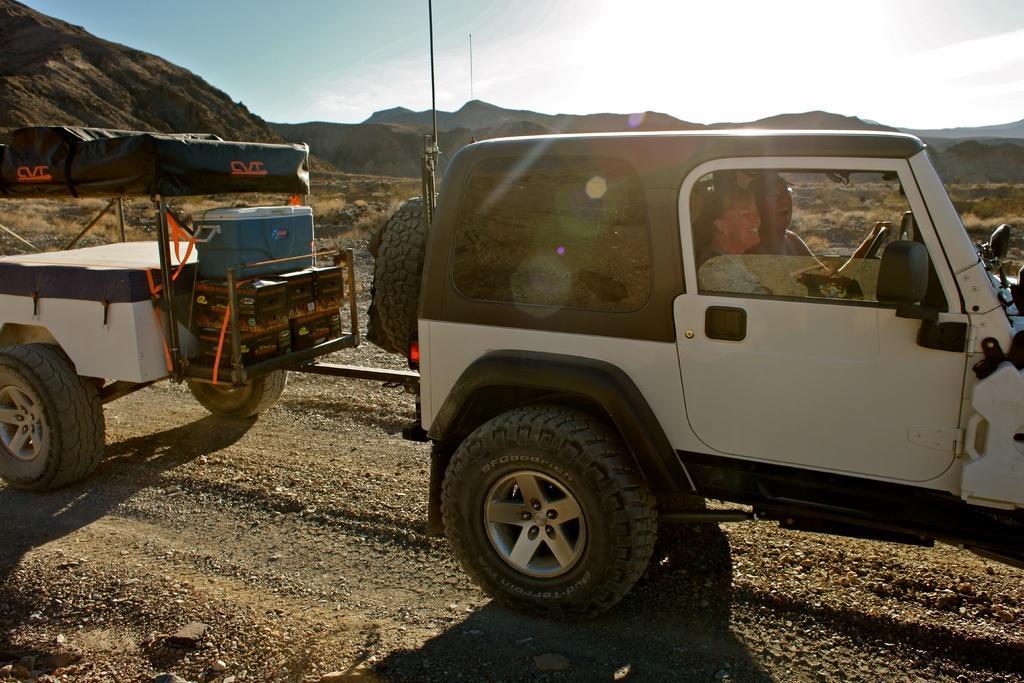Can you describe this image briefly? In this image I can see a vehicle which is white and black in color on the road and two persons sitting in the vehicle. Behind it I can see another vehicle which is white and black in color and few boxes in it. In the background I can see few mountains, the sky and some grass on the ground. 